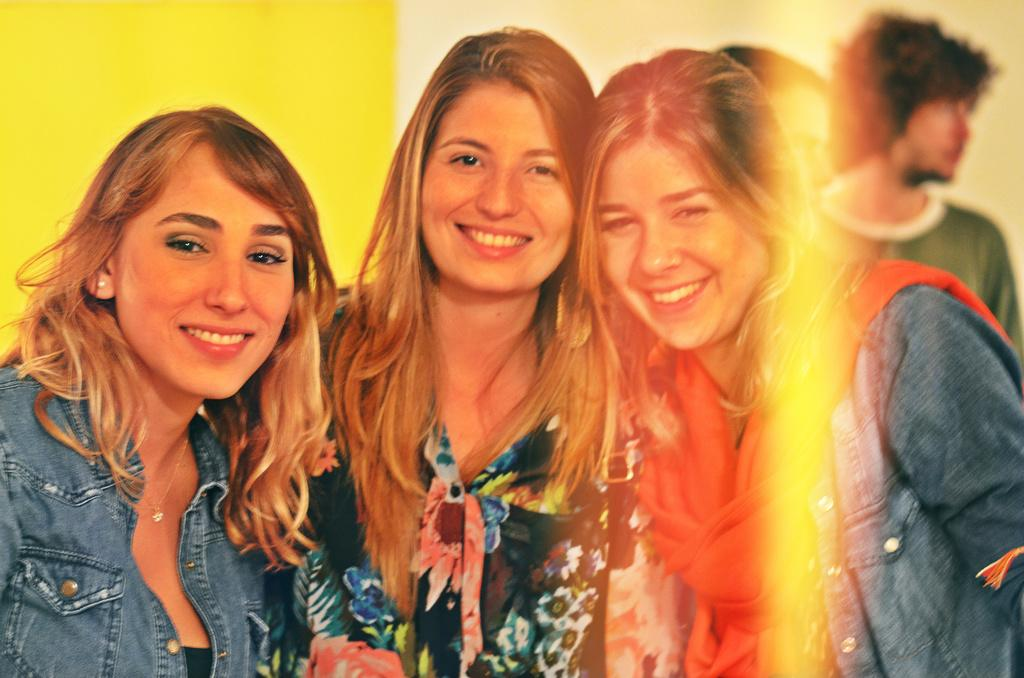What are the women in the image doing? The three women in the image are standing and smiling. Can you describe any editing or effects in the image? Yes, the image appears to be edited. Are there any other people visible in the image? Yes, there are two people standing in the background. What color is the wall in the background? The wall in the background is yellow. What type of plantation can be seen in the image? There is no plantation present in the image. How many ladybugs are visible on the women's clothing in the image? There are no ladybugs visible on the women's clothing in the image. 